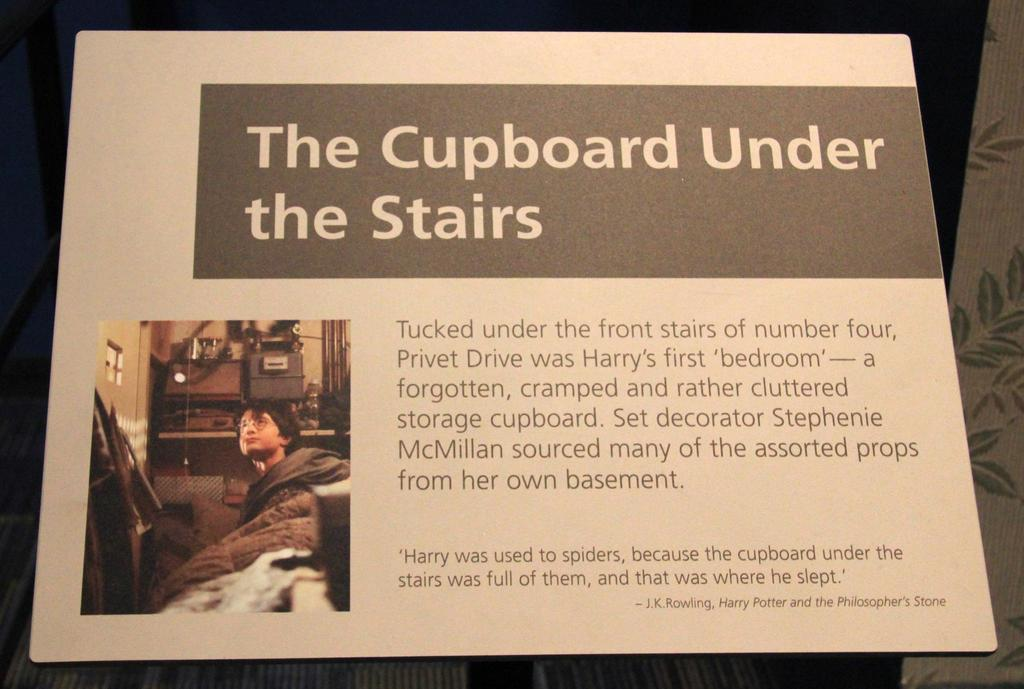<image>
Give a short and clear explanation of the subsequent image. display titled the cupboard under the stairs telling about where harry potter lived 